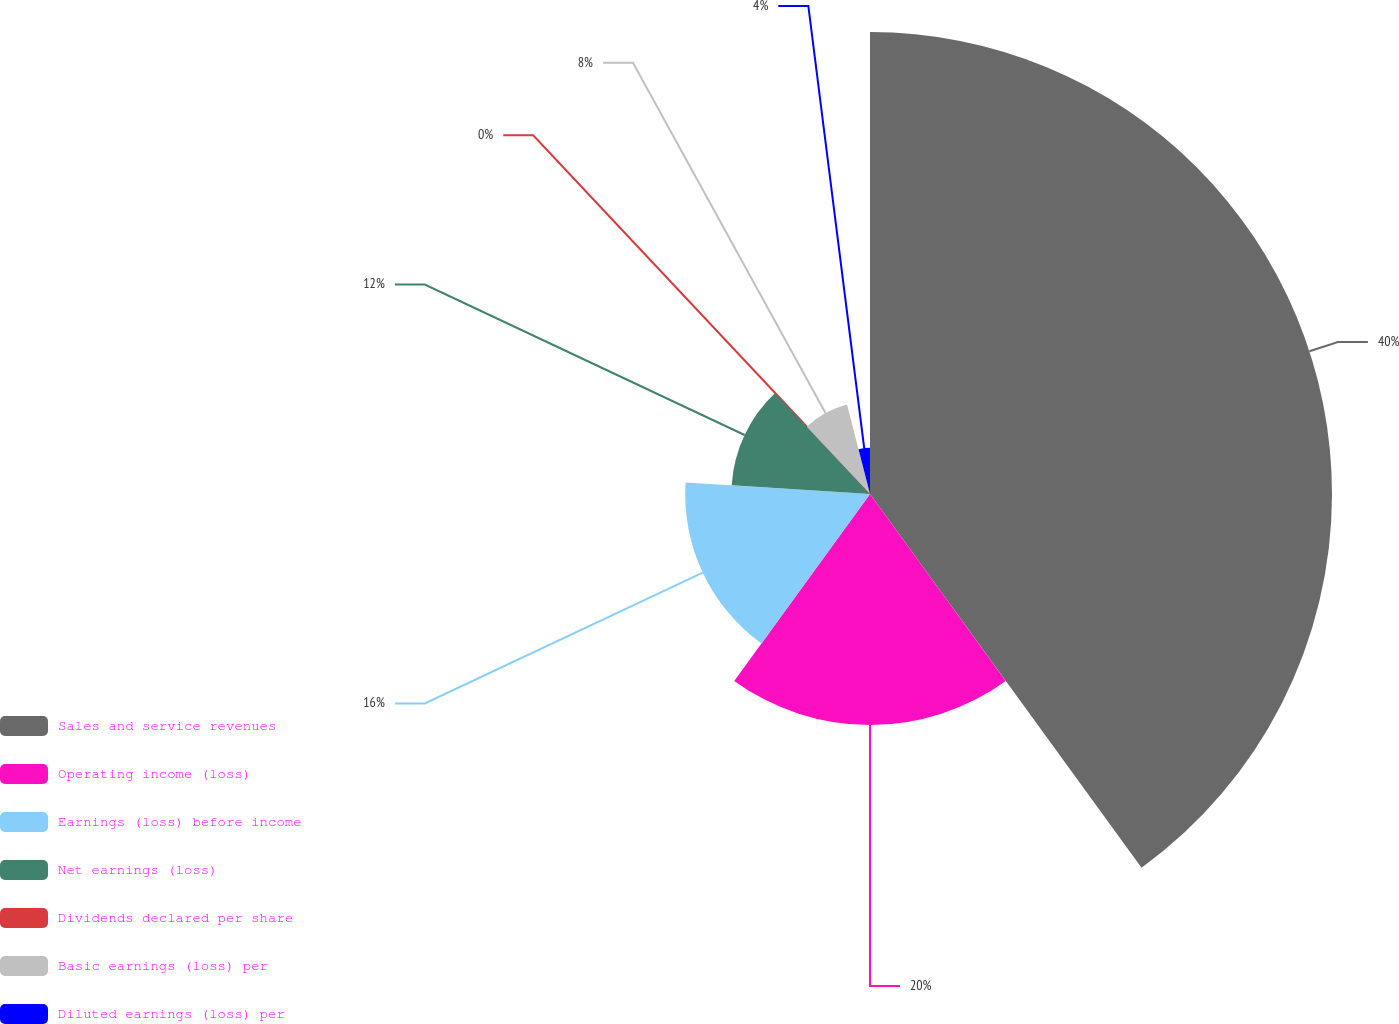<chart> <loc_0><loc_0><loc_500><loc_500><pie_chart><fcel>Sales and service revenues<fcel>Operating income (loss)<fcel>Earnings (loss) before income<fcel>Net earnings (loss)<fcel>Dividends declared per share<fcel>Basic earnings (loss) per<fcel>Diluted earnings (loss) per<nl><fcel>40.0%<fcel>20.0%<fcel>16.0%<fcel>12.0%<fcel>0.0%<fcel>8.0%<fcel>4.0%<nl></chart> 